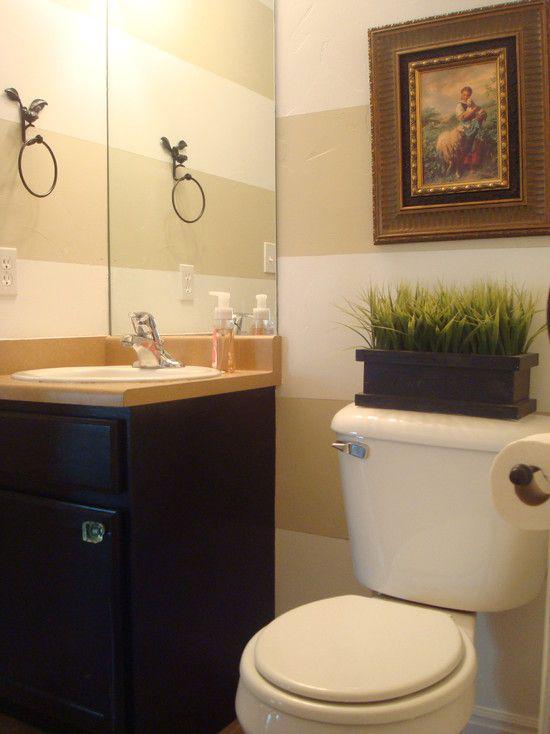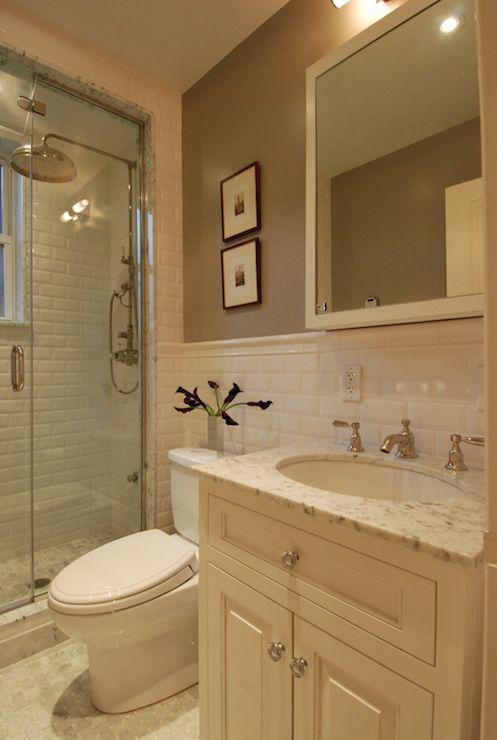The first image is the image on the left, the second image is the image on the right. Analyze the images presented: Is the assertion "The left image shows a dark vanity with a lighter countertop containing one inset sink with a faucet that is not wall-mounted, next to a traditional toilet with a tank." valid? Answer yes or no. Yes. The first image is the image on the left, the second image is the image on the right. For the images shown, is this caption "In one image, a shower stall is on the far end of a bathroom that also features a light colored vanity with one drawer and two doors." true? Answer yes or no. Yes. 